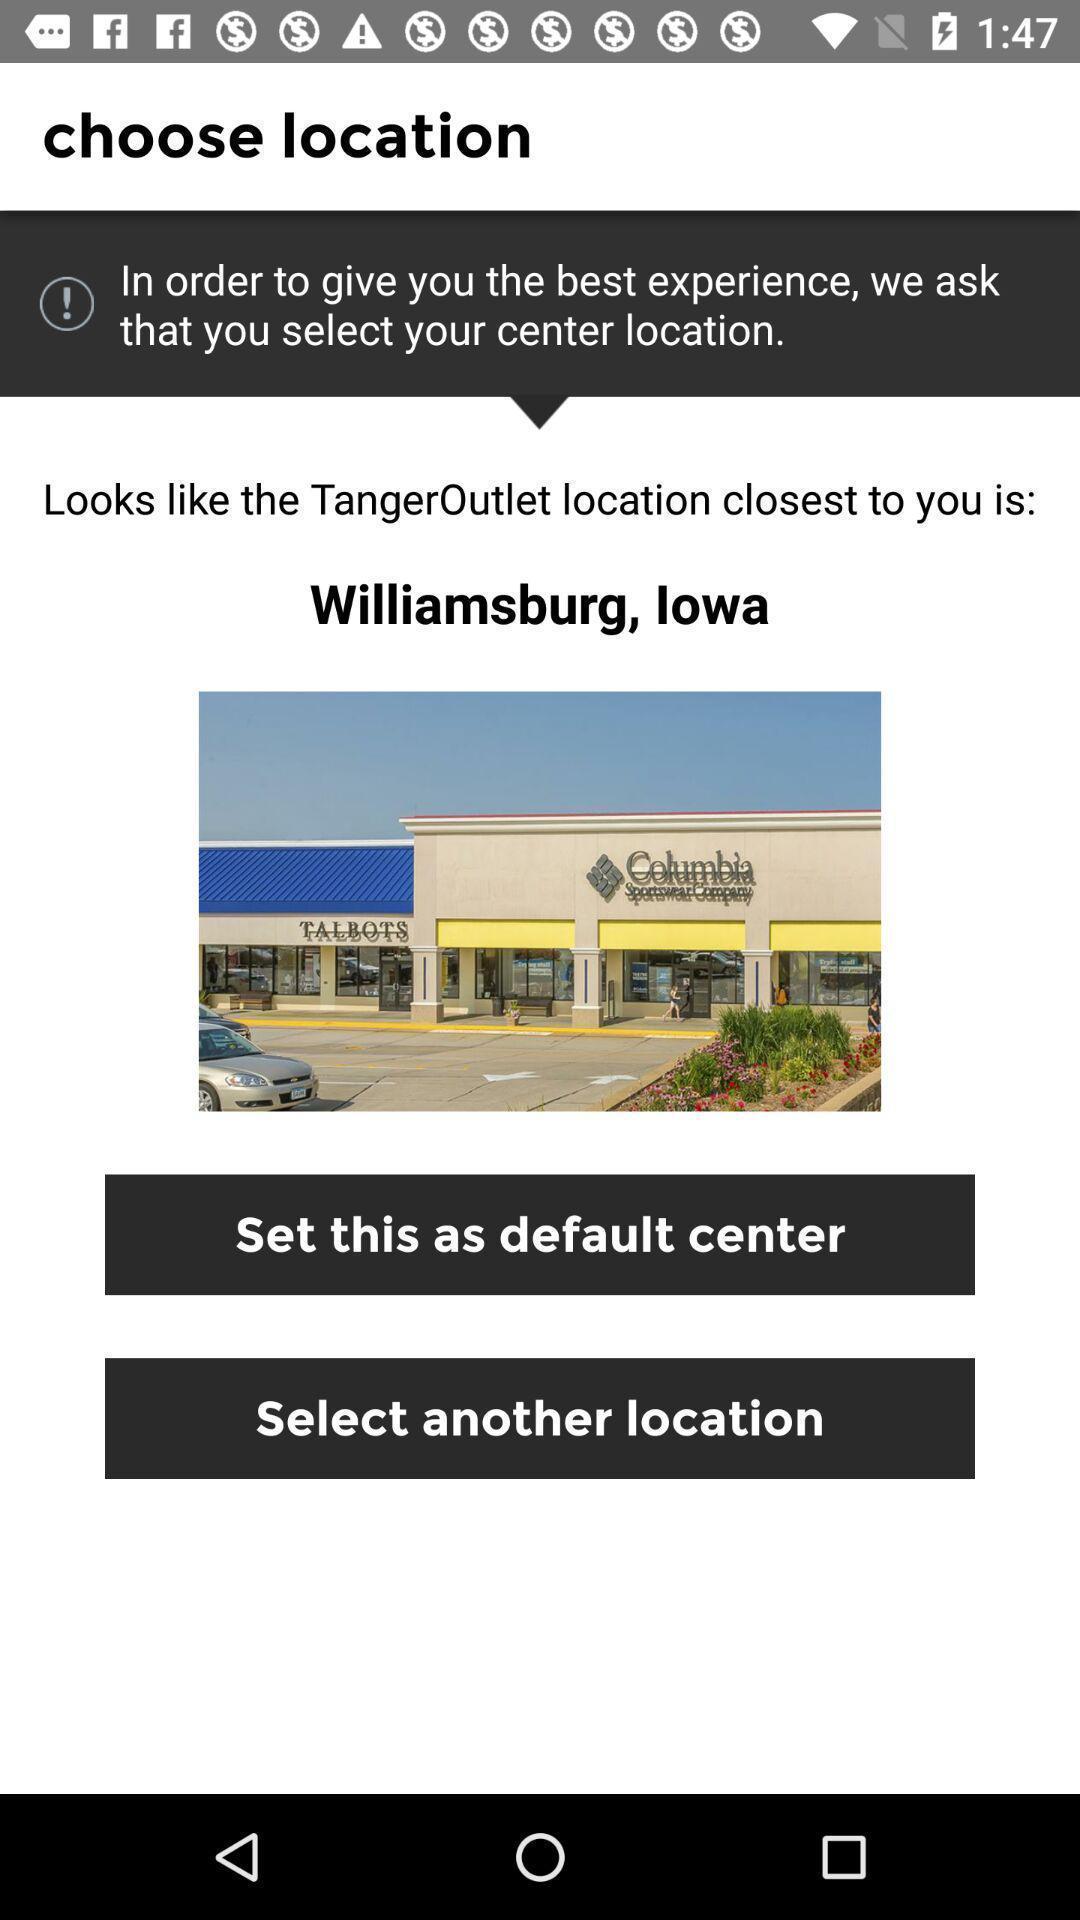Summarize the main components in this picture. Page showing to choose a location. 